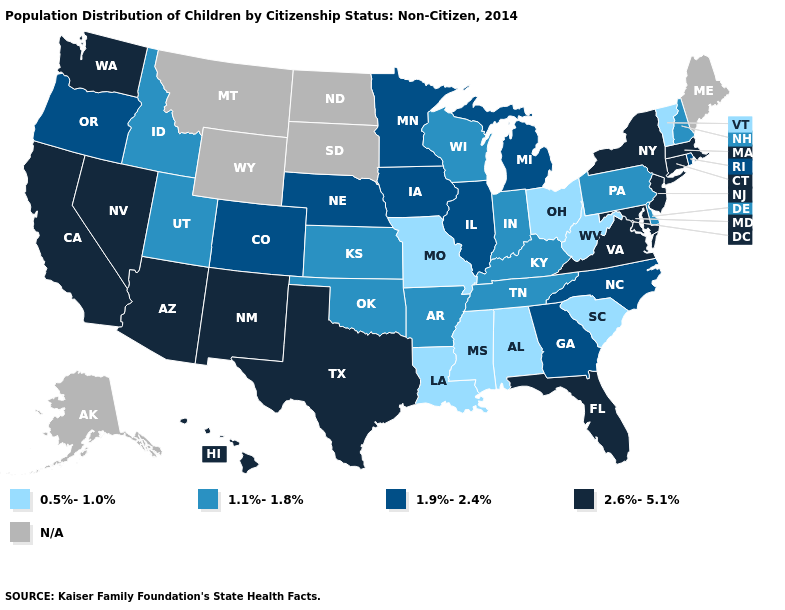Is the legend a continuous bar?
Answer briefly. No. What is the value of Kentucky?
Answer briefly. 1.1%-1.8%. Does Vermont have the lowest value in the USA?
Give a very brief answer. Yes. Name the states that have a value in the range 2.6%-5.1%?
Keep it brief. Arizona, California, Connecticut, Florida, Hawaii, Maryland, Massachusetts, Nevada, New Jersey, New Mexico, New York, Texas, Virginia, Washington. Which states have the lowest value in the West?
Give a very brief answer. Idaho, Utah. What is the value of Oklahoma?
Answer briefly. 1.1%-1.8%. Name the states that have a value in the range 1.1%-1.8%?
Keep it brief. Arkansas, Delaware, Idaho, Indiana, Kansas, Kentucky, New Hampshire, Oklahoma, Pennsylvania, Tennessee, Utah, Wisconsin. Name the states that have a value in the range 1.9%-2.4%?
Write a very short answer. Colorado, Georgia, Illinois, Iowa, Michigan, Minnesota, Nebraska, North Carolina, Oregon, Rhode Island. Which states have the lowest value in the Northeast?
Keep it brief. Vermont. Does Utah have the lowest value in the West?
Keep it brief. Yes. Name the states that have a value in the range 1.1%-1.8%?
Short answer required. Arkansas, Delaware, Idaho, Indiana, Kansas, Kentucky, New Hampshire, Oklahoma, Pennsylvania, Tennessee, Utah, Wisconsin. Name the states that have a value in the range 0.5%-1.0%?
Give a very brief answer. Alabama, Louisiana, Mississippi, Missouri, Ohio, South Carolina, Vermont, West Virginia. What is the value of Minnesota?
Give a very brief answer. 1.9%-2.4%. What is the highest value in the USA?
Be succinct. 2.6%-5.1%. What is the value of New Mexico?
Short answer required. 2.6%-5.1%. 